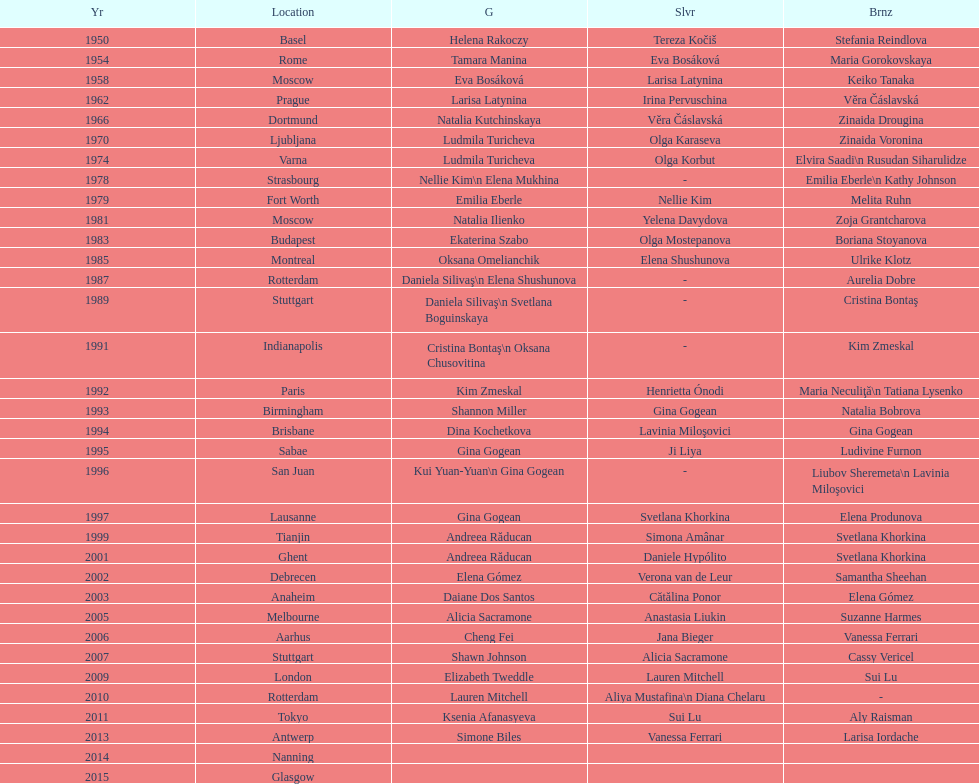What is the number of times a brazilian has won a medal? 2. 